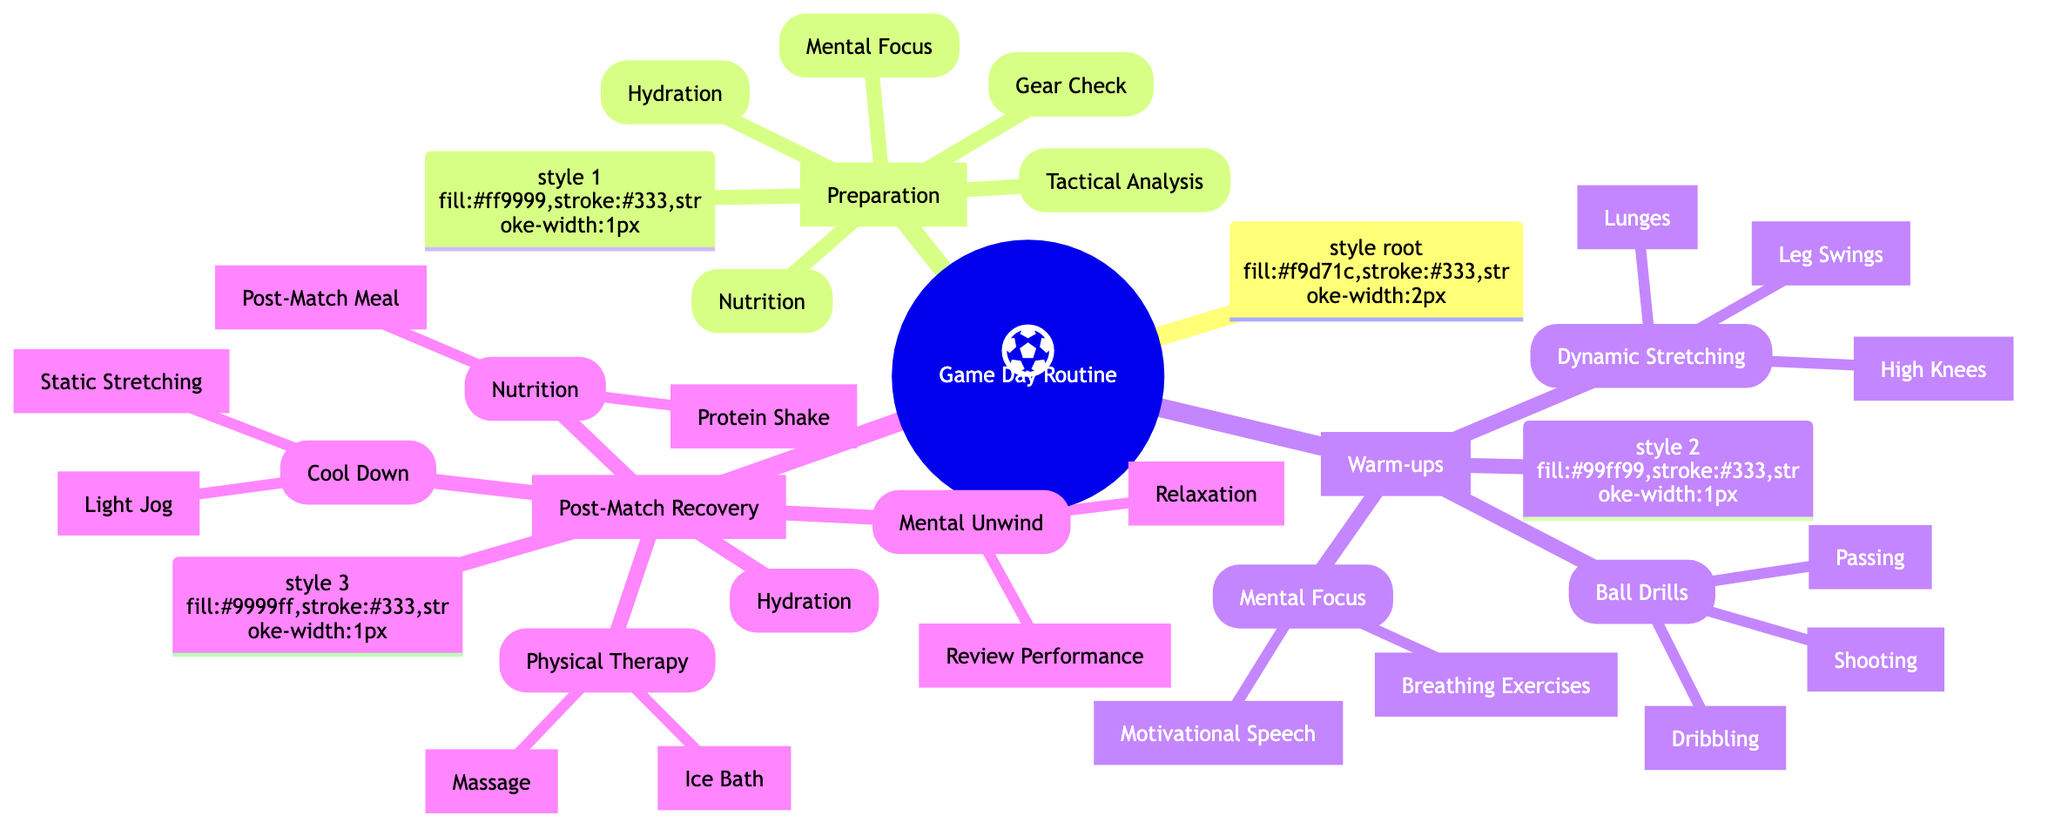What are the main categories of the Game Day Routine? The diagram has three main categories: Preparation, Warm-ups, and Post-Match Recovery, which are the main branches of the mind map.
Answer: Preparation, Warm-ups, Post-Match Recovery What type of stretching is included in the Warm-ups category? The Warm-ups category includes Dynamic Stretching as one of its subcategories, highlighting an organized aspect of preparation before the game.
Answer: Dynamic Stretching How many activities are listed under Post-Match Recovery? Under the Post-Match Recovery category, there are five activities: Cool Down, Nutrition, Hydration, Physical Therapy, and Mental Unwind, which can be counted directly from the diagram's branches.
Answer: 5 What is one component of the Mental Focus during Preparation? In the Preparation section, one of the components listed is Visualization of key plays and goals, which details a mental strategy to improve performance before the match.
Answer: Visualization of key plays and goals What activity follows Light Jog in the Cool Down section? In the Cool Down section, after Light Jog, the next activity listed is Static Stretching, which suggests the order of actions taken during post-match recovery.
Answer: Static Stretching What is the purpose of the Ice Bath in Post-Match Recovery? The Ice Bath is specifically mentioned under Physical Therapy, indicating its purpose is to reduce inflammation after a match, demonstrating a recovery technique used by players.
Answer: Reduce inflammation How many types of Ball Drills are mentioned in the Warm-ups? There are three types of Ball Drills mentioned: Dribbling, Shooting, and Passing, which can be counted as subcategories under the Ball Drills main category.
Answer: 3 Which activity is paired with Breathing Exercises for Mental Focus in Warm-ups? Motivational Speech is paired with Breathing Exercises in the Warm-ups section, indicating a strategy to enhance focus before the match.
Answer: Motivational Speech 